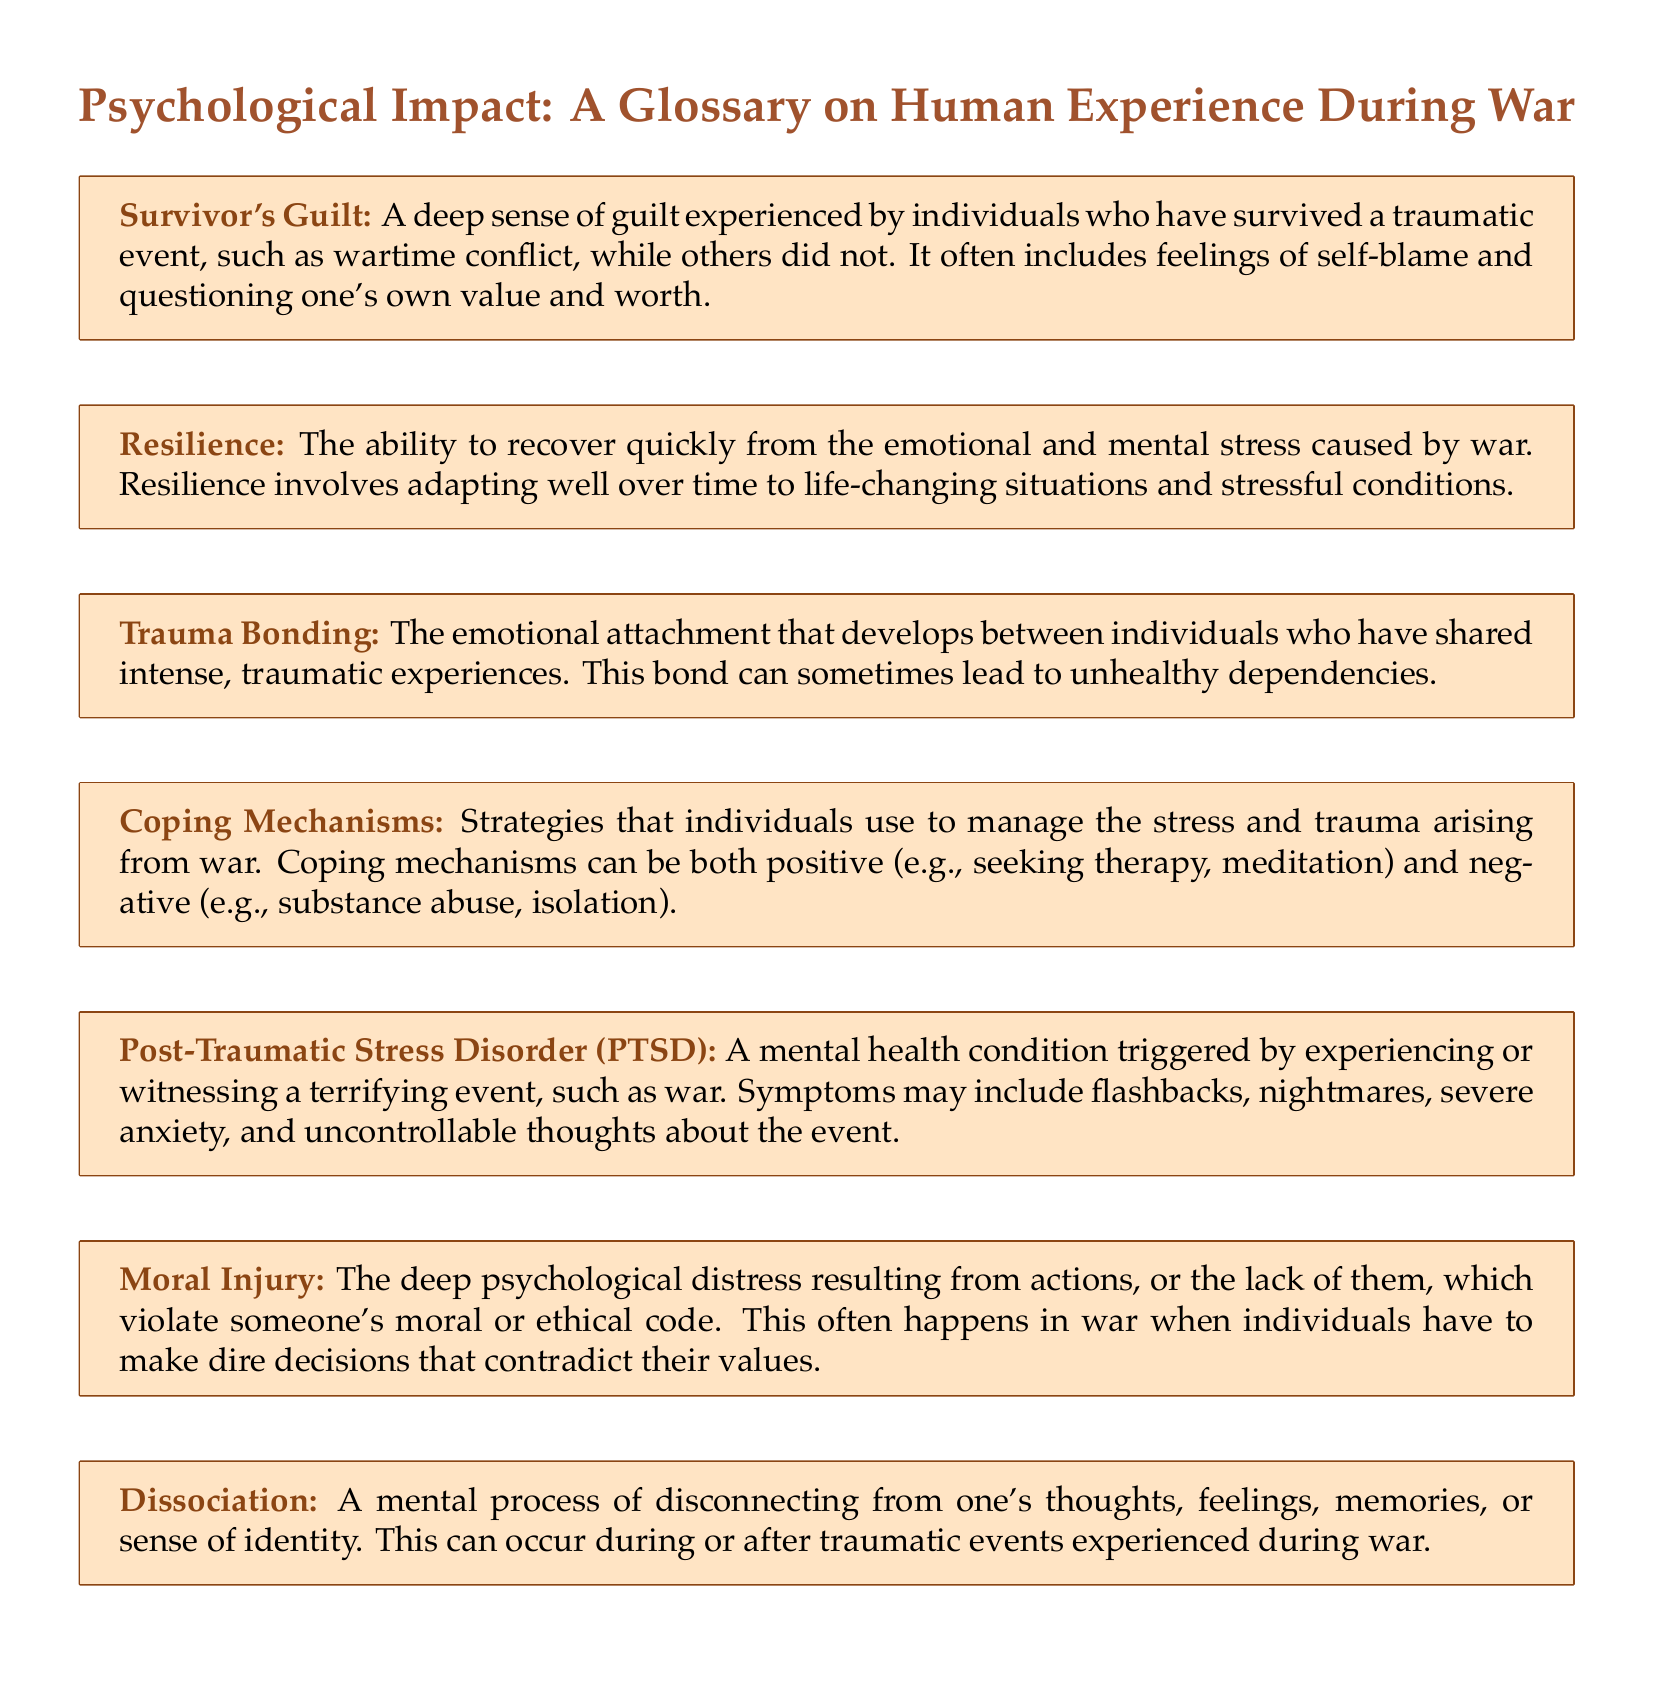What is survivor's guilt? Survivor's guilt is a term defined in the first box, describing guilt experienced by survivors of traumatic events.
Answer: A deep sense of guilt experienced by individuals who have survived a traumatic event What does resilience refer to in the context of war? Resilience is highlighted as the ability to recover from emotional and mental stress in relation to wartime experiences.
Answer: The ability to recover quickly from the emotional and mental stress caused by war What is trauma bonding? Trauma bonding is defined in the third box and refers to an emotional attachment formed through shared traumatic experiences.
Answer: The emotional attachment that develops between individuals who have shared intense, traumatic experiences What are coping mechanisms? The glossary explains coping mechanisms as strategies for managing stress and trauma arising from war.
Answer: Strategies that individuals use to manage the stress and trauma arising from war What condition can be triggered by experiencing war? The document lists PTSD as a condition resulting from experiencing or witnessing terrifying events, such as war.
Answer: Post-Traumatic Stress Disorder (PTSD) What is moral injury? Moral injury is described as psychological distress from actions that violate one's moral code in a war context.
Answer: The deep psychological distress resulting from actions, or the lack of them, which violate someone's moral or ethical code What is dissociation? Dissociation is defined as a mental disconnect from thoughts, feelings, and memories during or after trauma.
Answer: A mental process of disconnecting from one's thoughts, feelings, memories, or sense of identity 